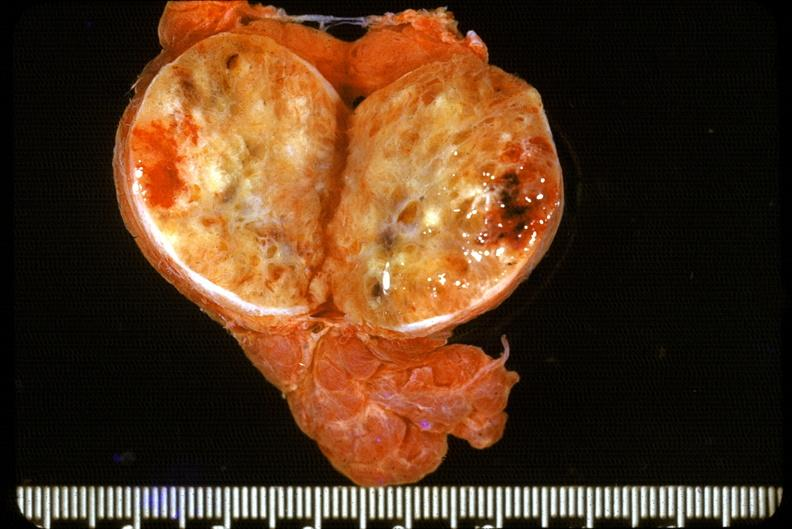s amyloidosis present?
Answer the question using a single word or phrase. No 